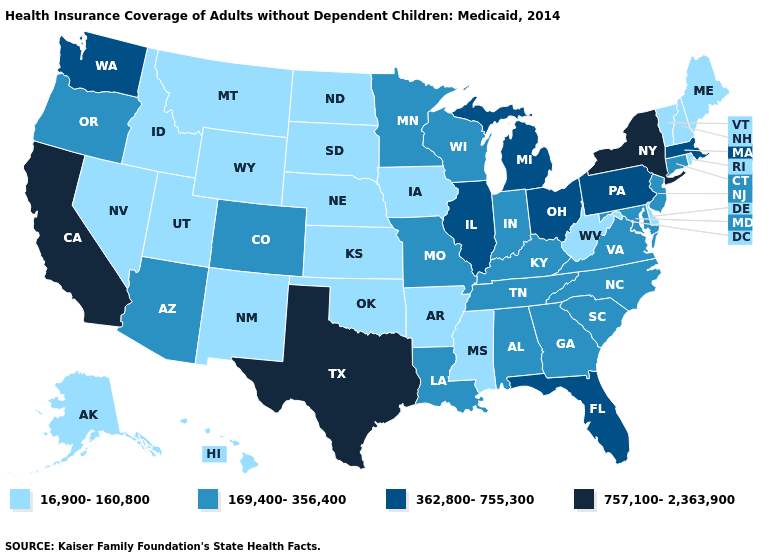What is the highest value in the West ?
Answer briefly. 757,100-2,363,900. Which states have the highest value in the USA?
Concise answer only. California, New York, Texas. Name the states that have a value in the range 169,400-356,400?
Short answer required. Alabama, Arizona, Colorado, Connecticut, Georgia, Indiana, Kentucky, Louisiana, Maryland, Minnesota, Missouri, New Jersey, North Carolina, Oregon, South Carolina, Tennessee, Virginia, Wisconsin. How many symbols are there in the legend?
Keep it brief. 4. What is the highest value in states that border South Dakota?
Concise answer only. 169,400-356,400. What is the value of Tennessee?
Be succinct. 169,400-356,400. Which states have the highest value in the USA?
Write a very short answer. California, New York, Texas. Name the states that have a value in the range 757,100-2,363,900?
Keep it brief. California, New York, Texas. What is the value of Missouri?
Short answer required. 169,400-356,400. What is the value of Arizona?
Write a very short answer. 169,400-356,400. Name the states that have a value in the range 16,900-160,800?
Concise answer only. Alaska, Arkansas, Delaware, Hawaii, Idaho, Iowa, Kansas, Maine, Mississippi, Montana, Nebraska, Nevada, New Hampshire, New Mexico, North Dakota, Oklahoma, Rhode Island, South Dakota, Utah, Vermont, West Virginia, Wyoming. What is the value of Utah?
Write a very short answer. 16,900-160,800. Does Texas have the highest value in the USA?
Give a very brief answer. Yes. Among the states that border Arizona , which have the highest value?
Give a very brief answer. California. Name the states that have a value in the range 16,900-160,800?
Concise answer only. Alaska, Arkansas, Delaware, Hawaii, Idaho, Iowa, Kansas, Maine, Mississippi, Montana, Nebraska, Nevada, New Hampshire, New Mexico, North Dakota, Oklahoma, Rhode Island, South Dakota, Utah, Vermont, West Virginia, Wyoming. 